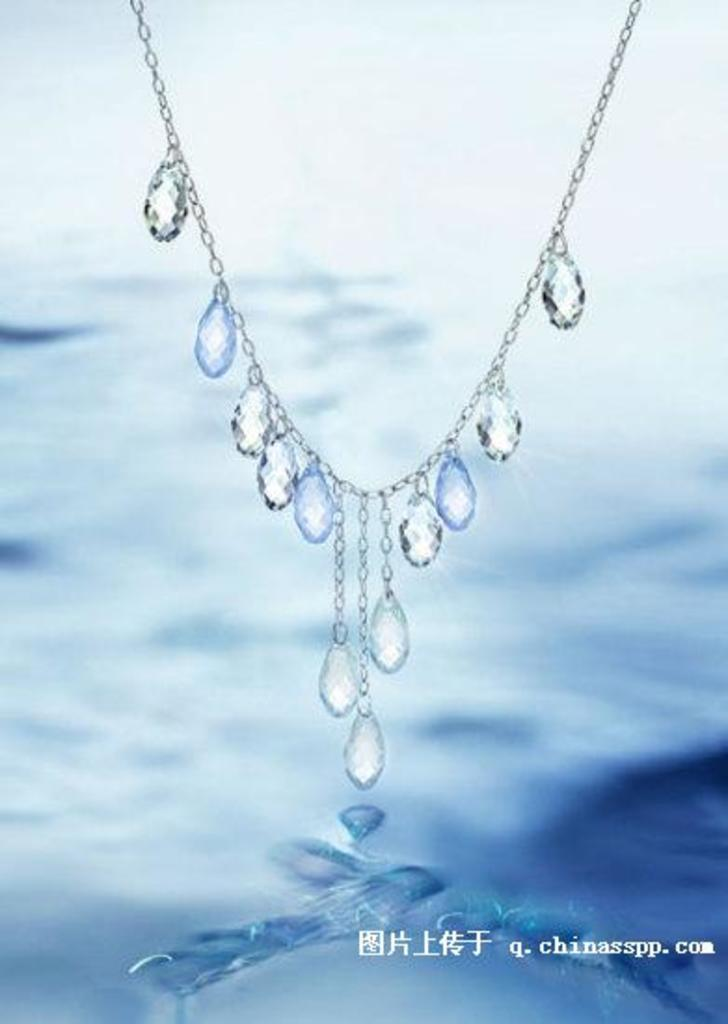What type of jewelry is visible in the image? There is a neck chain in the image. What are the special features of the neck chain? The neck chain has diamond stones. Can you describe any additional elements in the image? There is a watermark in the image. How would you describe the background of the image? The background of the image is blurred. What type of scent can be detected from the neck chain in the image? There is no mention of a scent associated with the neck chain in the image. 